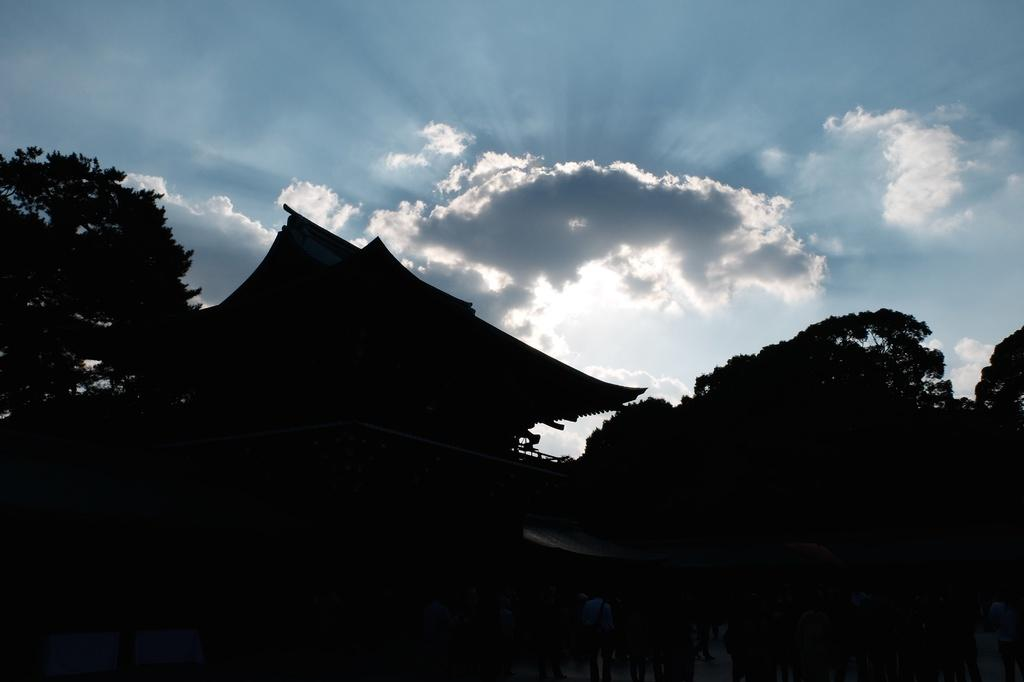What type of structure is present in the image? There is a building in the image. What type of vegetation can be seen in the image? There are trees in the image. What is visible in the background of the image? The sky with clouds is visible in the background of the image. What type of throat condition can be seen in the image? There is no throat condition present in the image. What type of bun is visible in the image? There is no bun present in the image. 